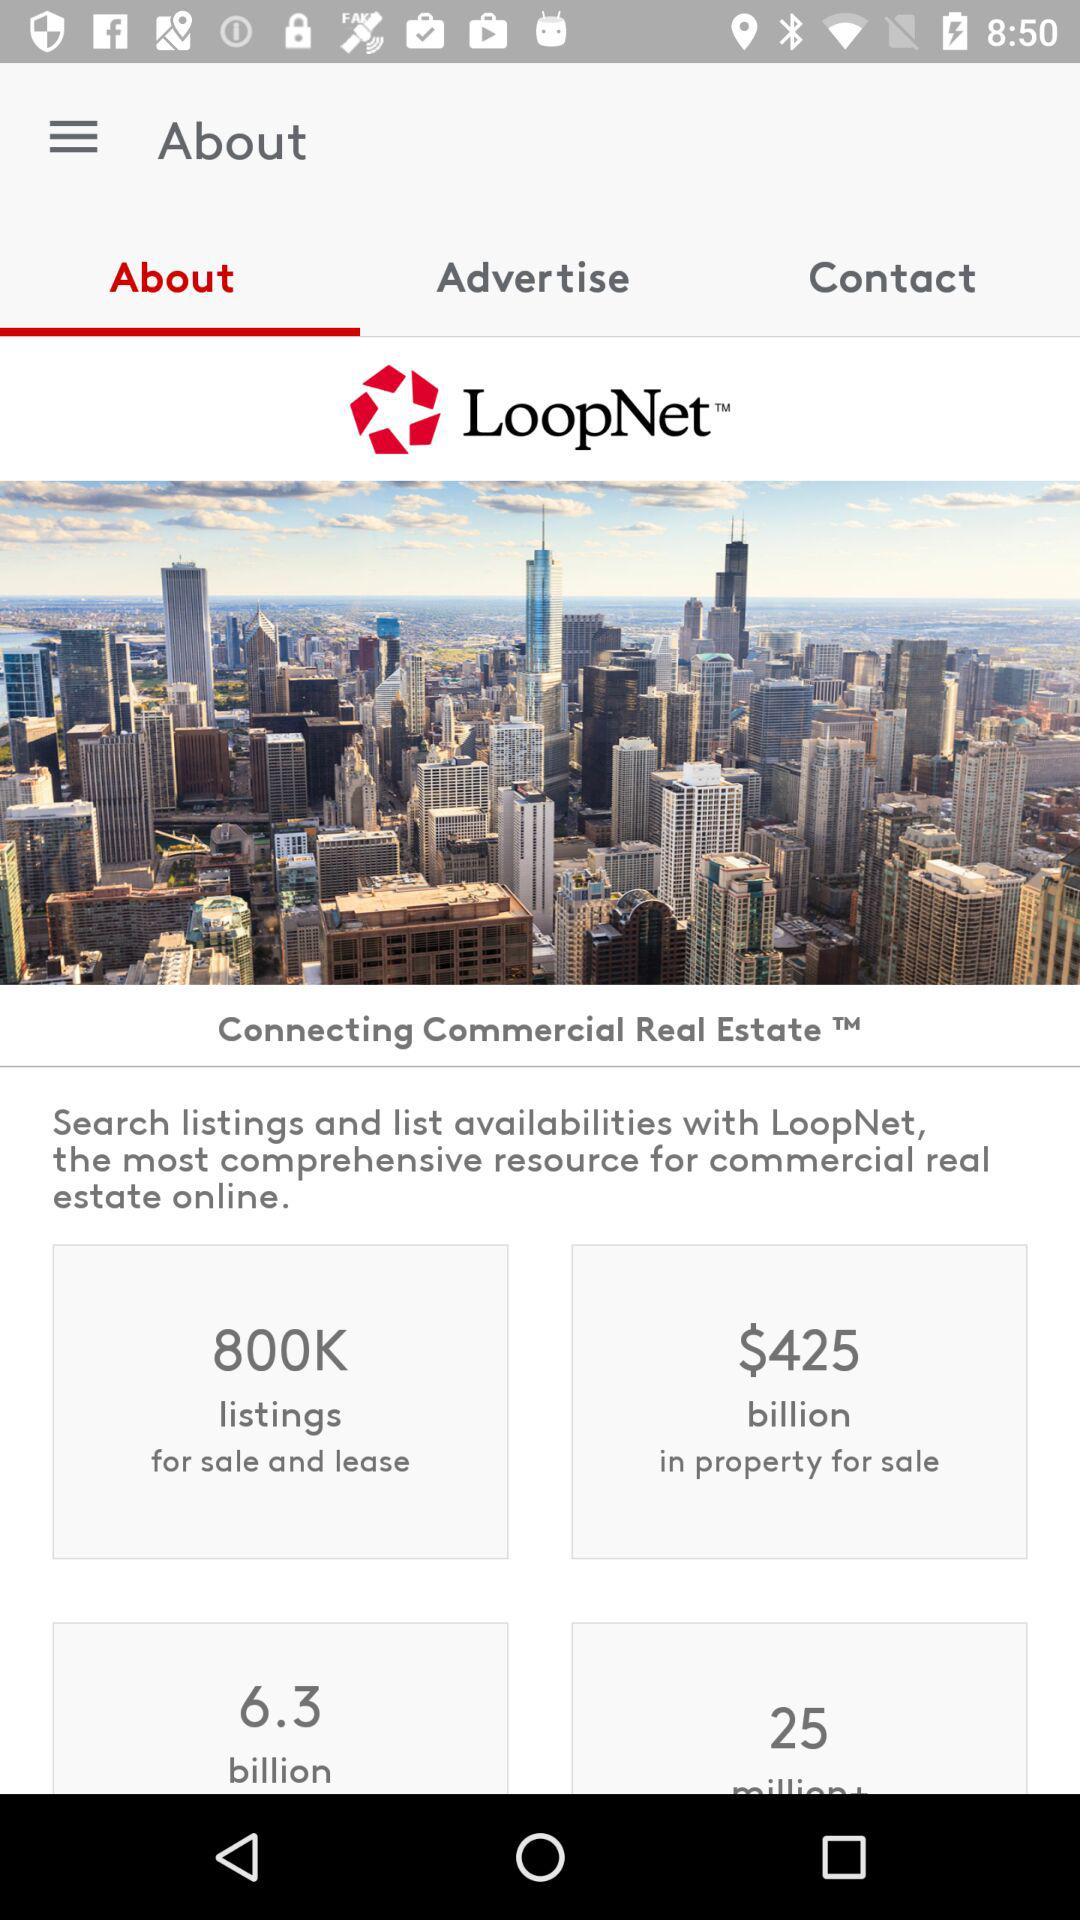How many people are available in property for sale?
When the provided information is insufficient, respond with <no answer>. <no answer> 